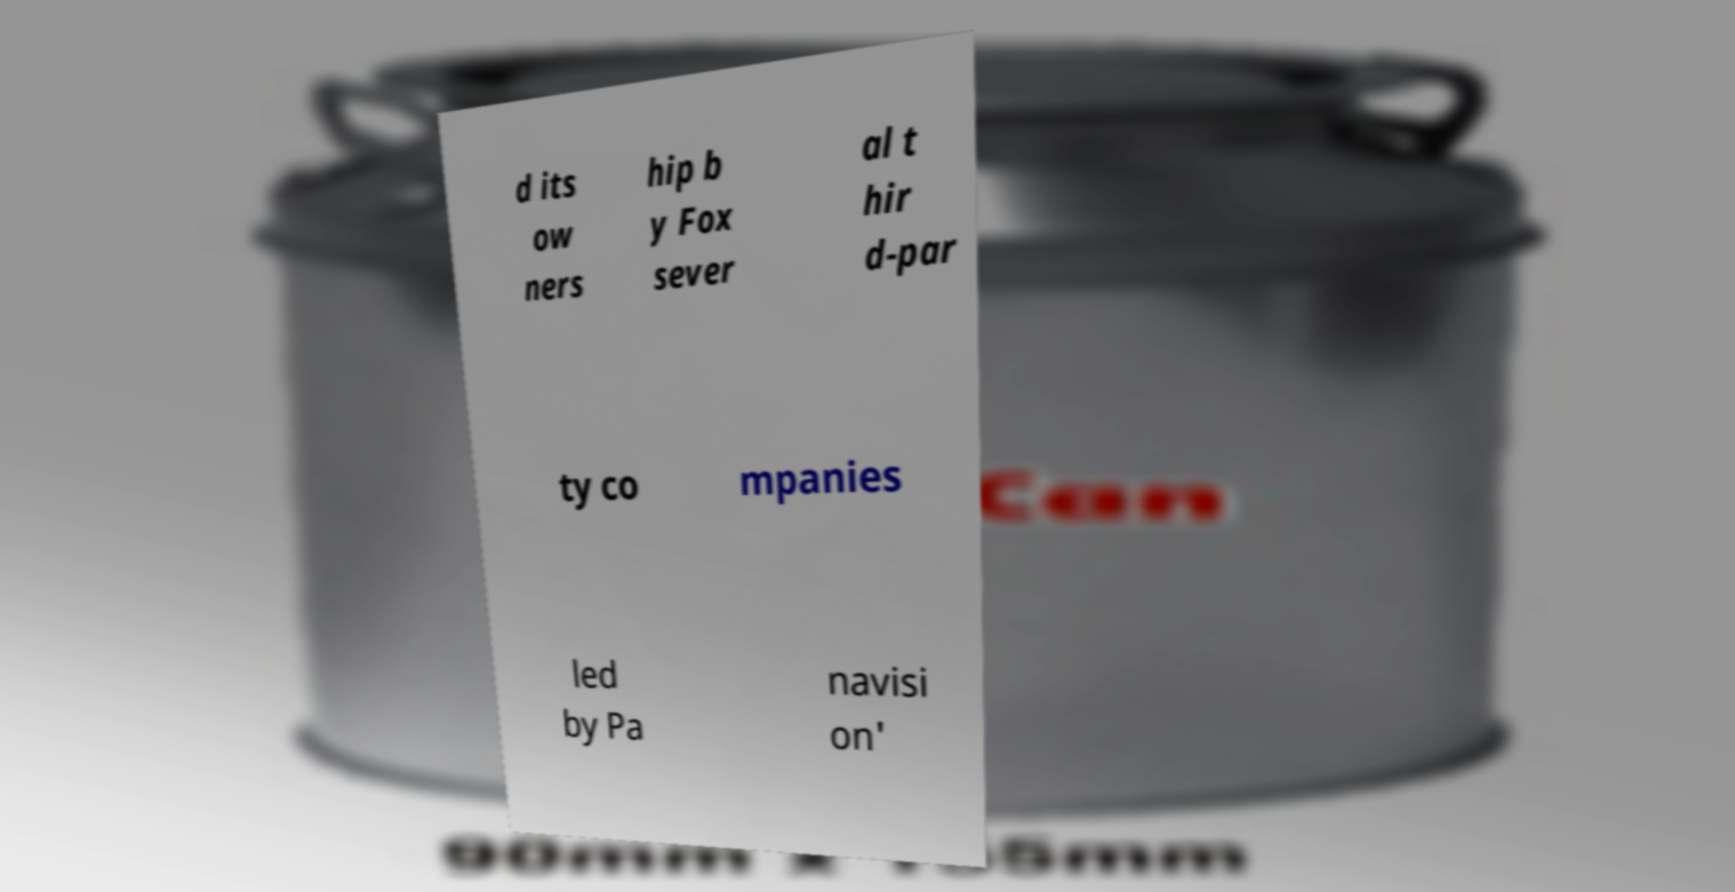Can you read and provide the text displayed in the image?This photo seems to have some interesting text. Can you extract and type it out for me? d its ow ners hip b y Fox sever al t hir d-par ty co mpanies led by Pa navisi on' 